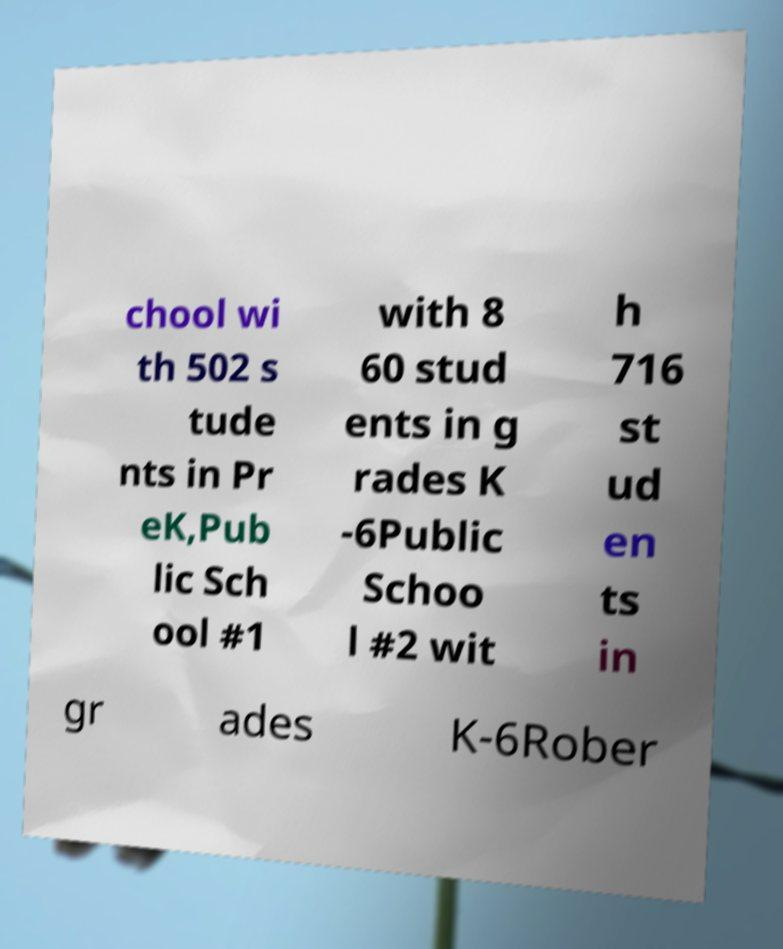For documentation purposes, I need the text within this image transcribed. Could you provide that? chool wi th 502 s tude nts in Pr eK,Pub lic Sch ool #1 with 8 60 stud ents in g rades K -6Public Schoo l #2 wit h 716 st ud en ts in gr ades K-6Rober 